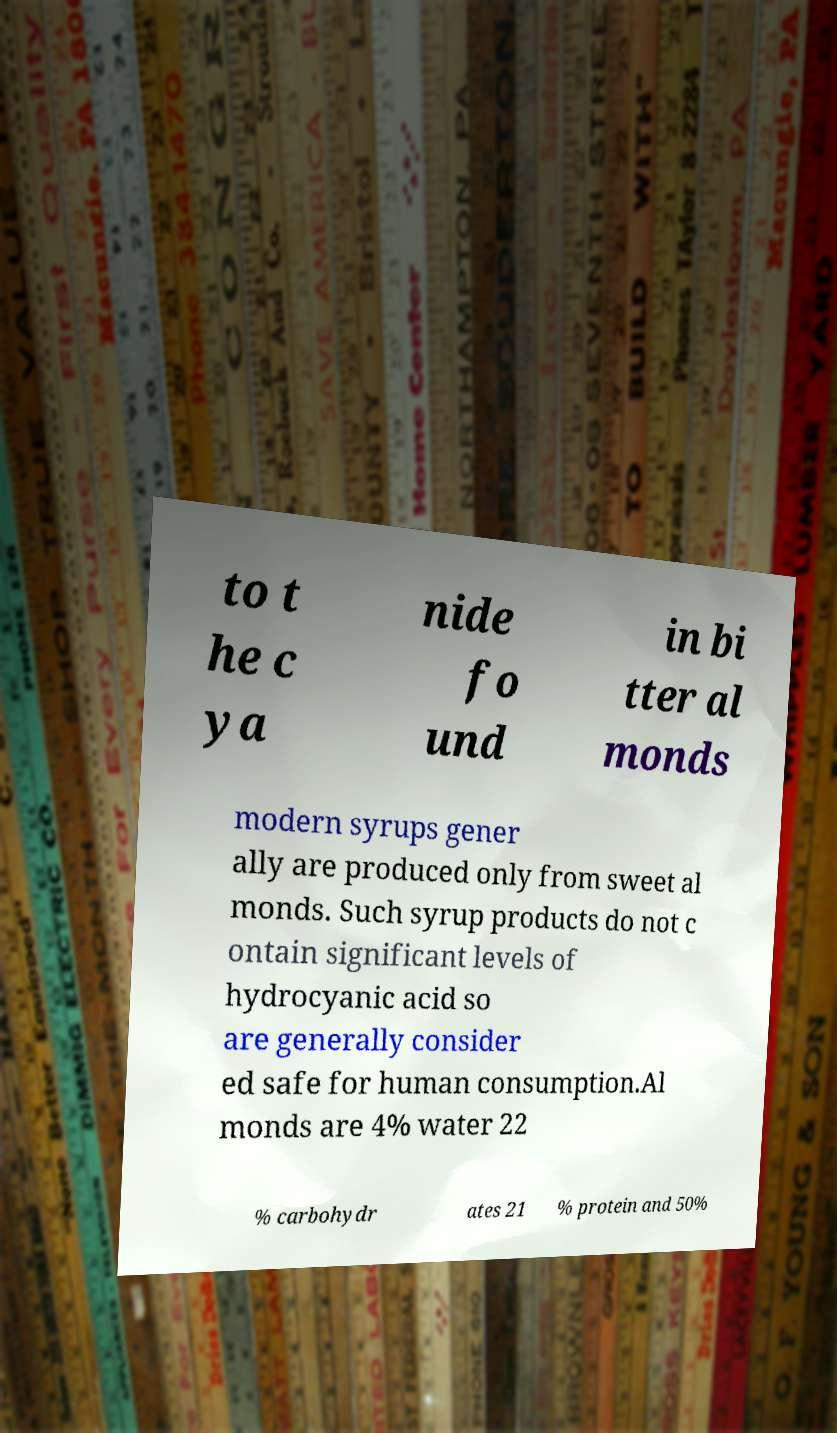Could you assist in decoding the text presented in this image and type it out clearly? to t he c ya nide fo und in bi tter al monds modern syrups gener ally are produced only from sweet al monds. Such syrup products do not c ontain significant levels of hydrocyanic acid so are generally consider ed safe for human consumption.Al monds are 4% water 22 % carbohydr ates 21 % protein and 50% 